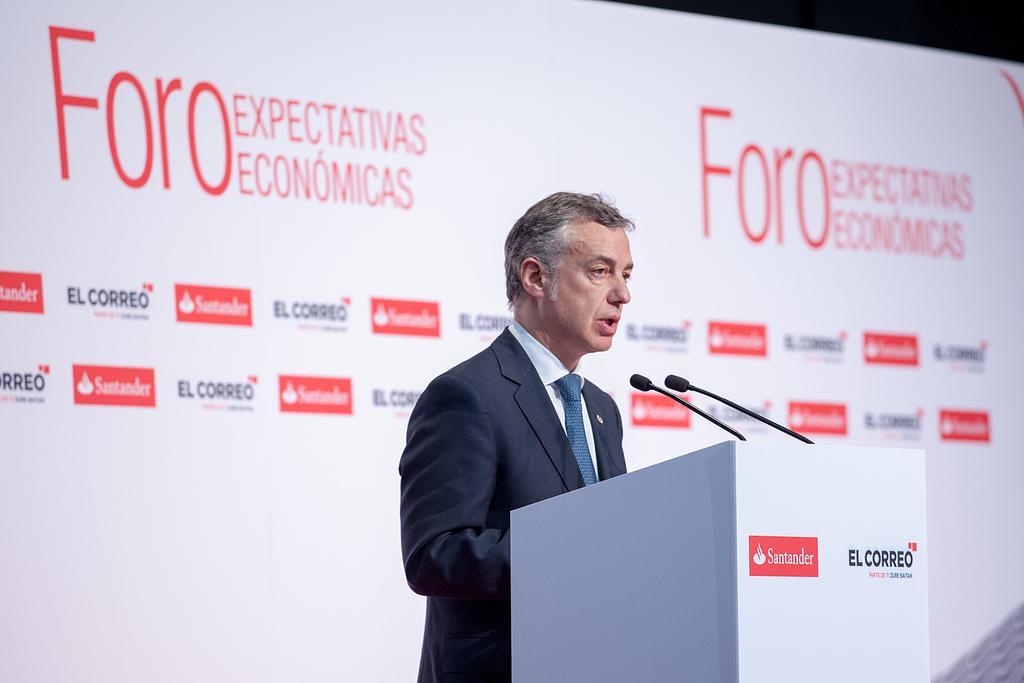How would you summarize this image in a sentence or two? In this image, we can see a person in front of the podium. In the background, we can see a cardboard banner. 